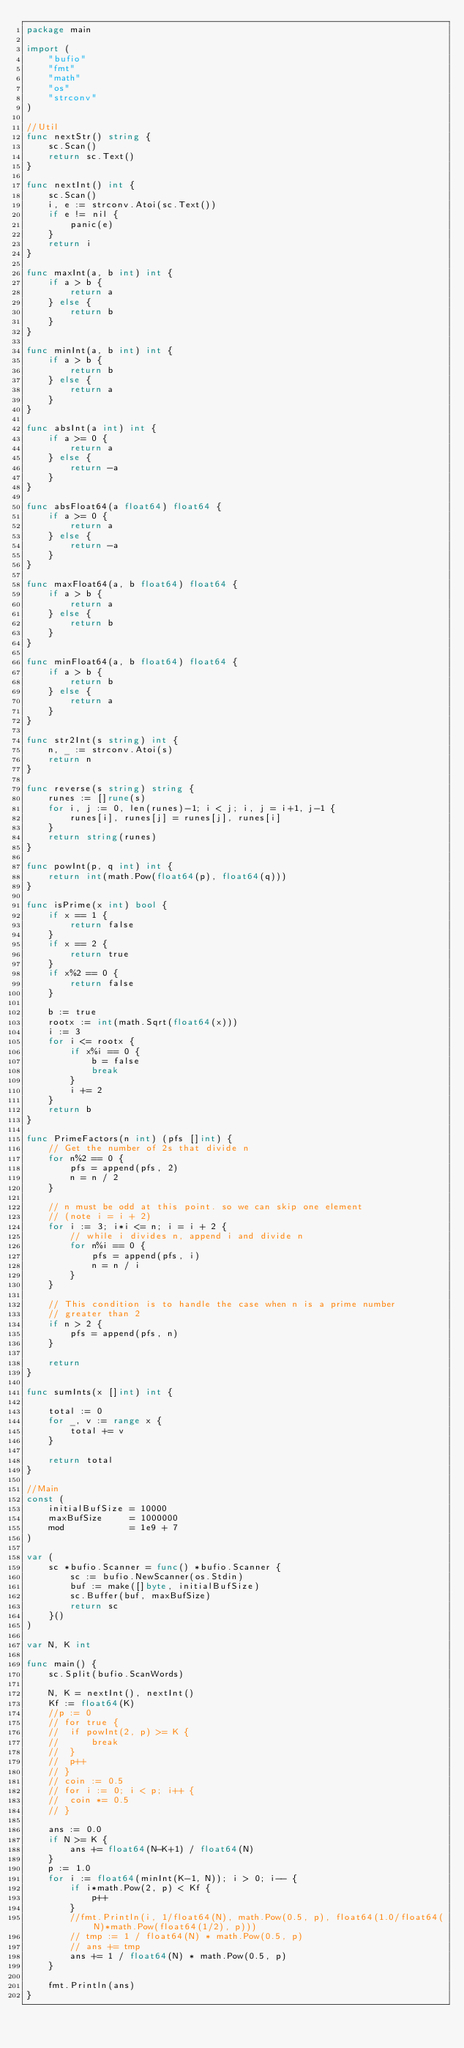<code> <loc_0><loc_0><loc_500><loc_500><_Go_>package main

import (
	"bufio"
	"fmt"
	"math"
	"os"
	"strconv"
)

//Util
func nextStr() string {
	sc.Scan()
	return sc.Text()
}

func nextInt() int {
	sc.Scan()
	i, e := strconv.Atoi(sc.Text())
	if e != nil {
		panic(e)
	}
	return i
}

func maxInt(a, b int) int {
	if a > b {
		return a
	} else {
		return b
	}
}

func minInt(a, b int) int {
	if a > b {
		return b
	} else {
		return a
	}
}

func absInt(a int) int {
	if a >= 0 {
		return a
	} else {
		return -a
	}
}

func absFloat64(a float64) float64 {
	if a >= 0 {
		return a
	} else {
		return -a
	}
}

func maxFloat64(a, b float64) float64 {
	if a > b {
		return a
	} else {
		return b
	}
}

func minFloat64(a, b float64) float64 {
	if a > b {
		return b
	} else {
		return a
	}
}

func str2Int(s string) int {
	n, _ := strconv.Atoi(s)
	return n
}

func reverse(s string) string {
	runes := []rune(s)
	for i, j := 0, len(runes)-1; i < j; i, j = i+1, j-1 {
		runes[i], runes[j] = runes[j], runes[i]
	}
	return string(runes)
}

func powInt(p, q int) int {
	return int(math.Pow(float64(p), float64(q)))
}

func isPrime(x int) bool {
	if x == 1 {
		return false
	}
	if x == 2 {
		return true
	}
	if x%2 == 0 {
		return false
	}

	b := true
	rootx := int(math.Sqrt(float64(x)))
	i := 3
	for i <= rootx {
		if x%i == 0 {
			b = false
			break
		}
		i += 2
	}
	return b
}

func PrimeFactors(n int) (pfs []int) {
	// Get the number of 2s that divide n
	for n%2 == 0 {
		pfs = append(pfs, 2)
		n = n / 2
	}

	// n must be odd at this point. so we can skip one element
	// (note i = i + 2)
	for i := 3; i*i <= n; i = i + 2 {
		// while i divides n, append i and divide n
		for n%i == 0 {
			pfs = append(pfs, i)
			n = n / i
		}
	}

	// This condition is to handle the case when n is a prime number
	// greater than 2
	if n > 2 {
		pfs = append(pfs, n)
	}

	return
}

func sumInts(x []int) int {

	total := 0
	for _, v := range x {
		total += v
	}

	return total
}

//Main
const (
	initialBufSize = 10000
	maxBufSize     = 1000000
	mod            = 1e9 + 7
)

var (
	sc *bufio.Scanner = func() *bufio.Scanner {
		sc := bufio.NewScanner(os.Stdin)
		buf := make([]byte, initialBufSize)
		sc.Buffer(buf, maxBufSize)
		return sc
	}()
)

var N, K int

func main() {
	sc.Split(bufio.ScanWords)

	N, K = nextInt(), nextInt()
	Kf := float64(K)
	//p := 0
	// for true {
	// 	if powInt(2, p) >= K {
	// 		break
	// 	}
	// 	p++
	// }
	// coin := 0.5
	// for i := 0; i < p; i++ {
	// 	coin *= 0.5
	// }

	ans := 0.0
	if N >= K {
		ans += float64(N-K+1) / float64(N)
	}
	p := 1.0
	for i := float64(minInt(K-1, N)); i > 0; i-- {
		if i*math.Pow(2, p) < Kf {
			p++
		}
		//fmt.Println(i, 1/float64(N), math.Pow(0.5, p), float64(1.0/float64(N)*math.Pow(float64(1/2), p)))
		// tmp := 1 / float64(N) * math.Pow(0.5, p)
		// ans += tmp
		ans += 1 / float64(N) * math.Pow(0.5, p)
	}

	fmt.Println(ans)
}
</code> 